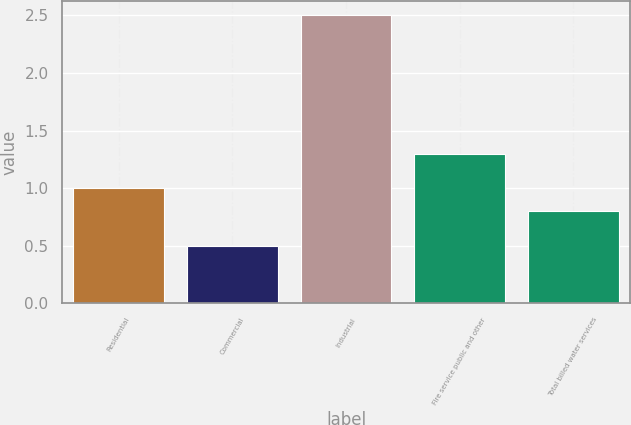Convert chart to OTSL. <chart><loc_0><loc_0><loc_500><loc_500><bar_chart><fcel>Residential<fcel>Commercial<fcel>Industrial<fcel>Fire service public and other<fcel>Total billed water services<nl><fcel>1<fcel>0.5<fcel>2.5<fcel>1.3<fcel>0.8<nl></chart> 